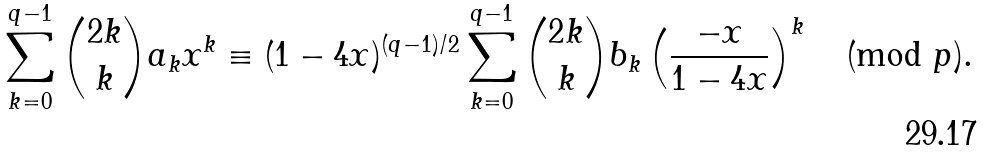Convert formula to latex. <formula><loc_0><loc_0><loc_500><loc_500>\sum _ { k = 0 } ^ { q - 1 } \binom { 2 k } { k } a _ { k } x ^ { k } \equiv ( 1 - 4 x ) ^ { ( q - 1 ) / 2 } \sum _ { k = 0 } ^ { q - 1 } \binom { 2 k } { k } b _ { k } \left ( \frac { - x } { 1 - 4 x } \right ) ^ { k } \pmod { p } .</formula> 